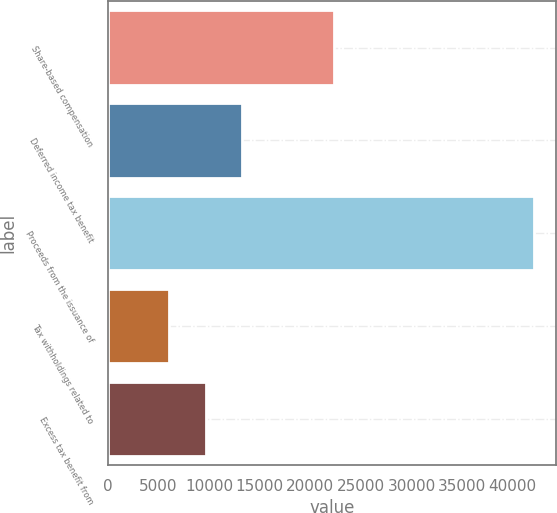Convert chart to OTSL. <chart><loc_0><loc_0><loc_500><loc_500><bar_chart><fcel>Share-based compensation<fcel>Deferred income tax benefit<fcel>Proceeds from the issuance of<fcel>Tax withholdings related to<fcel>Excess tax benefit from<nl><fcel>22311<fcel>13269.6<fcel>42160<fcel>6047<fcel>9658.3<nl></chart> 